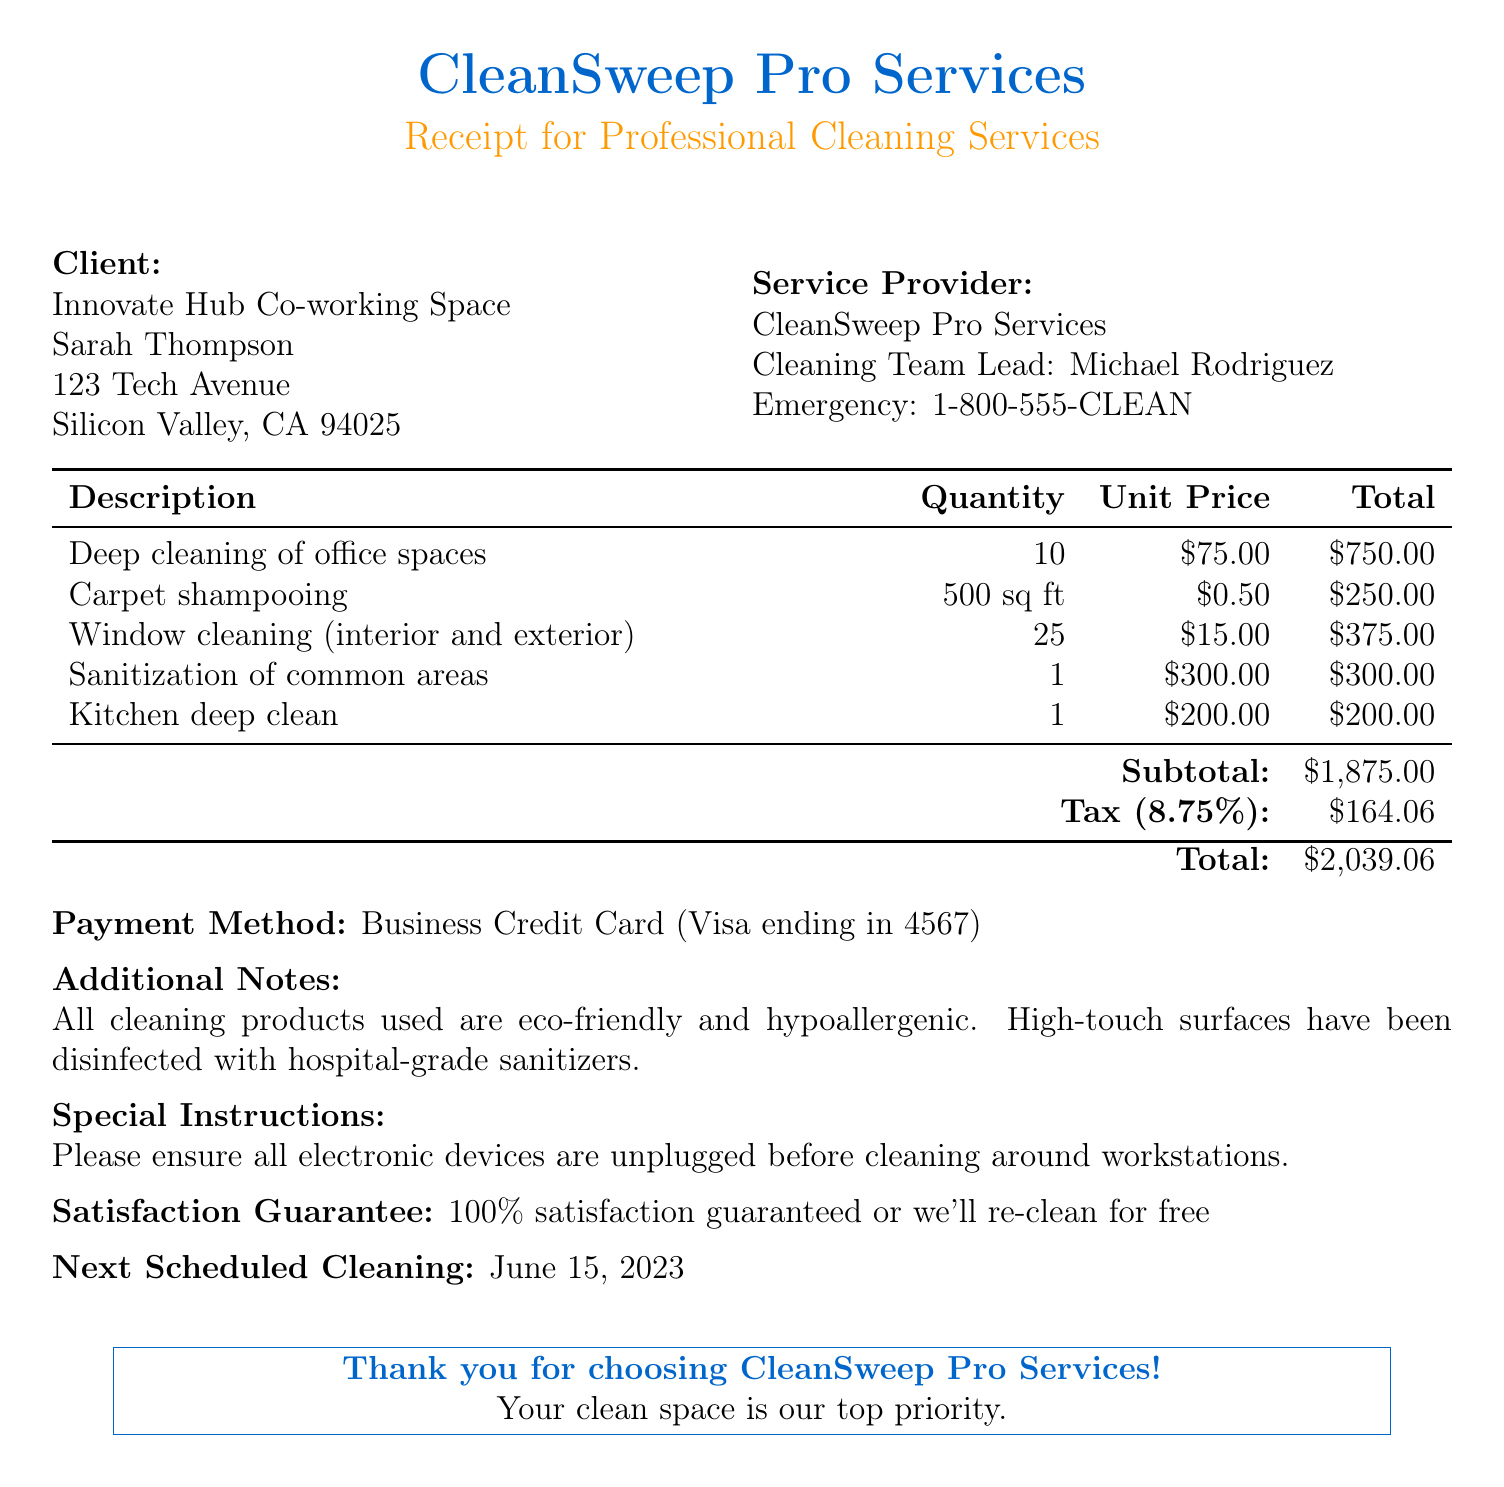What is the name of the business? The name of the business is listed prominently in the document under the client information section.
Answer: Innovate Hub Co-working Space Who is the owner of the business? The owner's name is provided alongside the business name, indicating the individual responsible for the establishment.
Answer: Sarah Thompson What is the total amount due for the cleaning services? The total amount is calculated by adding the subtotal and tax, specifically shown at the bottom of the document.
Answer: $2,039.06 What date was the service performed? The date of service is stated near the top of the document, clearly indicating when the cleaning took place.
Answer: May 15, 2023 How many square feet of carpet were shampooed? The quantity for carpet shampooing is specified in the services table of the document.
Answer: 500 sq ft What is included in the satisfaction guarantee? The satisfaction guarantee is presented in a specific section, highlighting the commitment of the service provider.
Answer: 100% satisfaction guaranteed or we'll re-clean for free Who is the cleaning team lead? The name of the cleaning team lead is provided under the service provider details in the document.
Answer: Michael Rodriguez What is the next scheduled cleaning date? This information is detailed towards the end of the document, indicating the follow-up cleaning service date.
Answer: June 15, 2023 What payment method was used for the transaction? The payment method is mentioned in the document, detailing how the service was paid for.
Answer: Business Credit Card (Visa ending in 4567) 